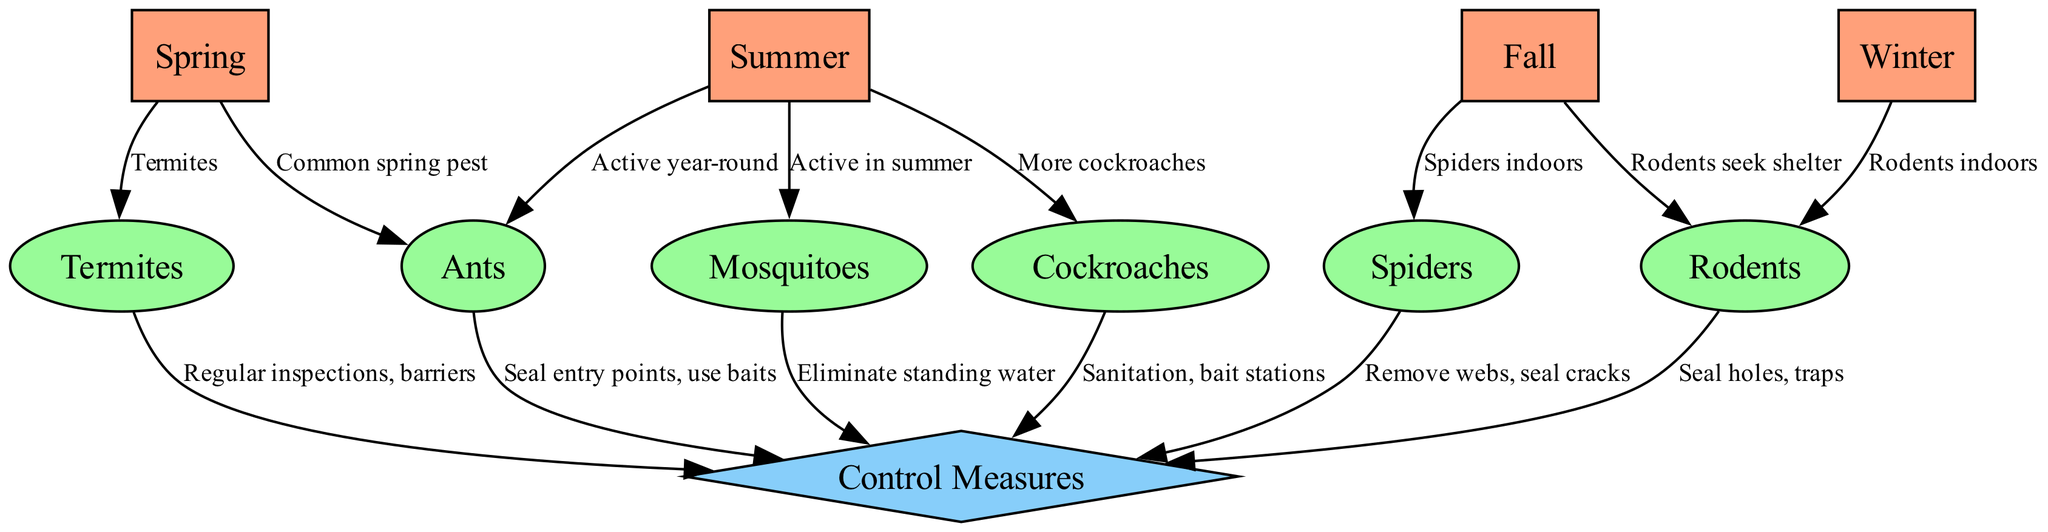What are common pests in spring? The diagram indicates that both ants and termites are labeled as common spring pests. This is shown by the directed edges from the Spring node to the Ants and Termites nodes, signifying their presence during that particular season.
Answer: Ants, Termites Which pest is active in summer? From the diagram, the mosquitoes are highlighted as being active in the summer season. This is indicated by the directed edge from the Summer node to the Mosquitoes node, along with the label that states "Active in summer."
Answer: Mosquitoes How many main seasons are represented in the diagram? The diagram includes four main nodes that represent the seasons: Spring, Summer, Fall, and Winter. Counting these nodes provides a total, which can be easily identified in the nodes section of the diagram.
Answer: 4 What control measure is associated with cockroaches? The directed edge from the Cockroaches node to the Control Measures node indicates that the control measures associated with cockroaches include sanitation and bait stations. This relationship is directly stated in the diagram.
Answer: Sanitation, bait stations In which season do rodents seek shelter? The diagram shows that rodents seek shelter in the fall season, as evidenced by the directed edge from the Fall node to the Rodents node with the label "Rodents seek shelter." Therefore, fall is identified as the season for this behavior.
Answer: Fall Which pest is primarily connected to winter in the diagram? The diagram indicates that rodents are primarily connected to winter, as there is a directed edge from the Winter node to the Rodents node stating "Rodents indoors." Hence, rodents are the focus in winter.
Answer: Rodents What seasonal activity is noted for ants across the year? The diagram specifies that ants are active year-round. This is indicated by a directed edge from the Summer node to the Ants node along with the label "Active year-round," demonstrating their persistent presence across all seasons.
Answer: Active year-round What is a recommended control measure for spiders? The directed edge from the Spiders node to the Control Measures node describes recommended actions for managing spiders, which include removing webs and sealing cracks, forming the basis of effective spider control.
Answer: Remove webs, seal cracks 